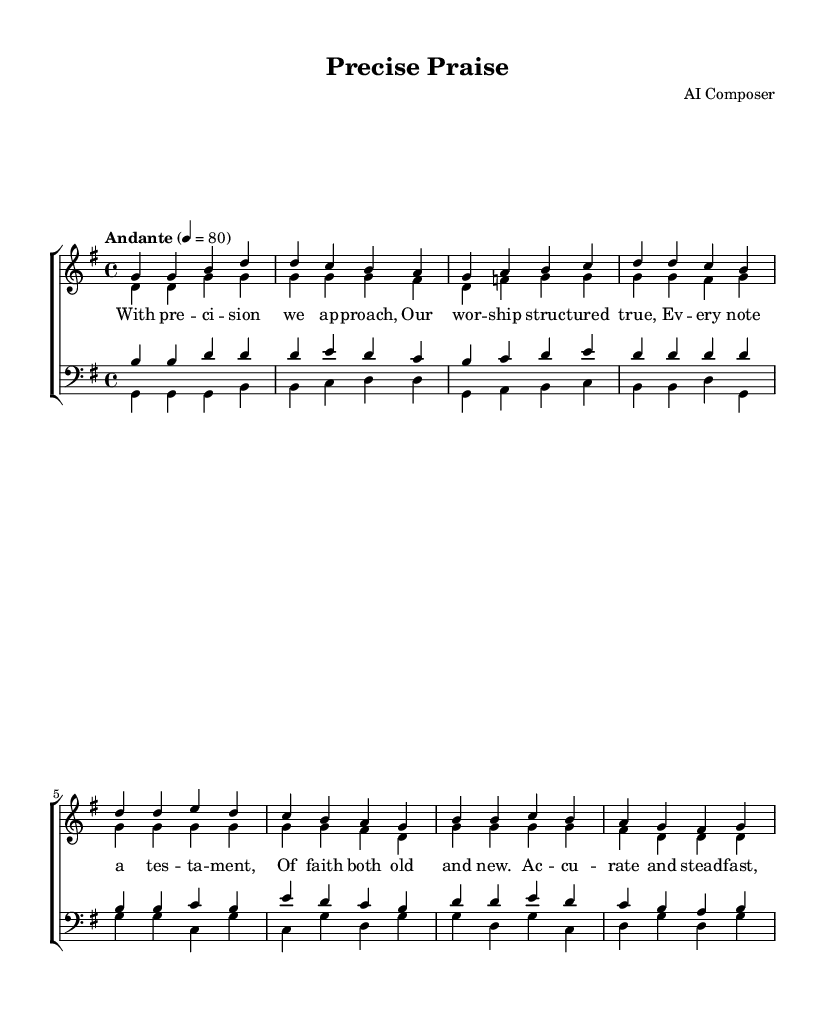What is the key signature of this music? The key signature is indicated by the symbols at the beginning of the staff. In this case, it shows one sharp, indicating that the piece is in G major.
Answer: G major What is the time signature of this music? The time signature is located at the beginning of the score. It shows "4/4", which means there are four beats in each measure and the quarter note gets one beat.
Answer: 4/4 What is the tempo marking of this music? The tempo marking is specified above the staff and reads "Andante" with the metronome marking of quarter note equals 80. This indicates a moderate pace.
Answer: Andante How many verses are present in the soprano section? Looking specifically at the soprano part, I see two sections labeled as "Verse" and "Chorus," which indicates the music is structured with one verse followed by one chorus.
Answer: 1 What is the primary theme conveyed in the lyrics of the chorus? The lyrics of the chorus focus on characteristics of worship, emphasizing accuracy and steadfastness in the praise to God, portraying the quality of the music as meticulous and transcendent.
Answer: Accuracy and steadfastness What melodic range does the tenor part primarily cover? By observing the notes written for the tenor, it appears that the range is from B to G, indicating that it does not have the lowest and highest notes but remains in a middle range typical for tenor voices.
Answer: B to G What is the overall structural format of this piece? The piece follows a standard hymn structure often found in religious music with distinct verse and chorus sections, which alternately present the lyrical themes, creating a call-and-response feeling typical in worship settings.
Answer: Verse and Chorus 